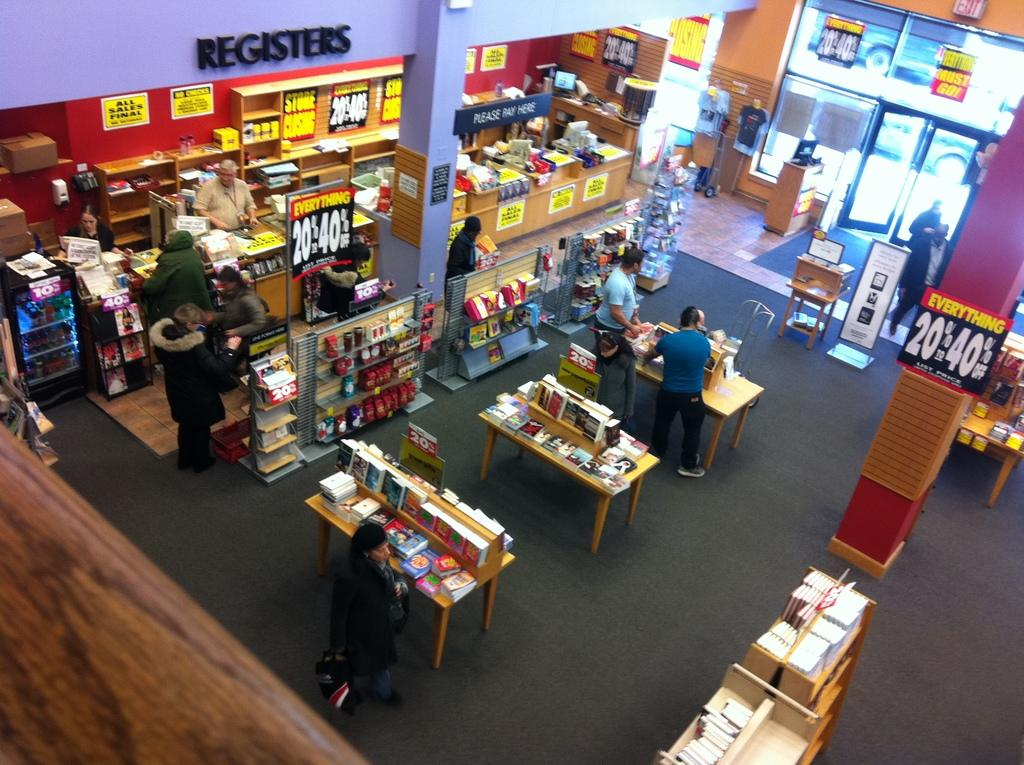<image>
Write a terse but informative summary of the picture. Top view of a book store that says EVERYTHING is 20-40% off. 